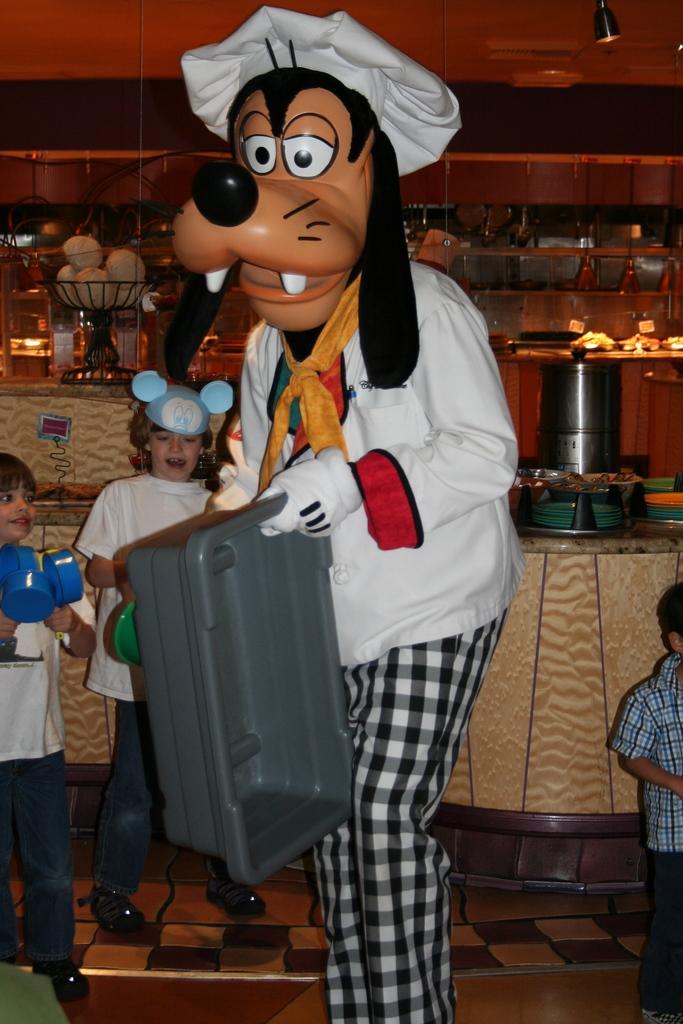Please provide a concise description of this image. As we can see in the image there are few people, tiles, tray, wall, shelves and table. 